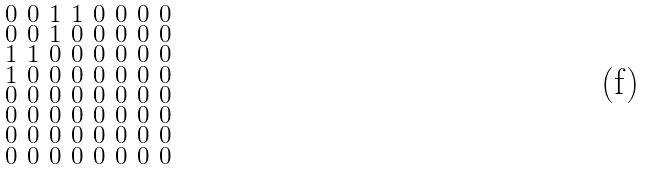Convert formula to latex. <formula><loc_0><loc_0><loc_500><loc_500>\begin{smallmatrix} 0 & 0 & 1 & 1 & 0 & 0 & 0 & 0 \\ 0 & 0 & 1 & 0 & 0 & 0 & 0 & 0 \\ 1 & 1 & 0 & 0 & 0 & 0 & 0 & 0 \\ 1 & 0 & 0 & 0 & 0 & 0 & 0 & 0 \\ 0 & 0 & 0 & 0 & 0 & 0 & 0 & 0 \\ 0 & 0 & 0 & 0 & 0 & 0 & 0 & 0 \\ 0 & 0 & 0 & 0 & 0 & 0 & 0 & 0 \\ 0 & 0 & 0 & 0 & 0 & 0 & 0 & 0 \end{smallmatrix}</formula> 